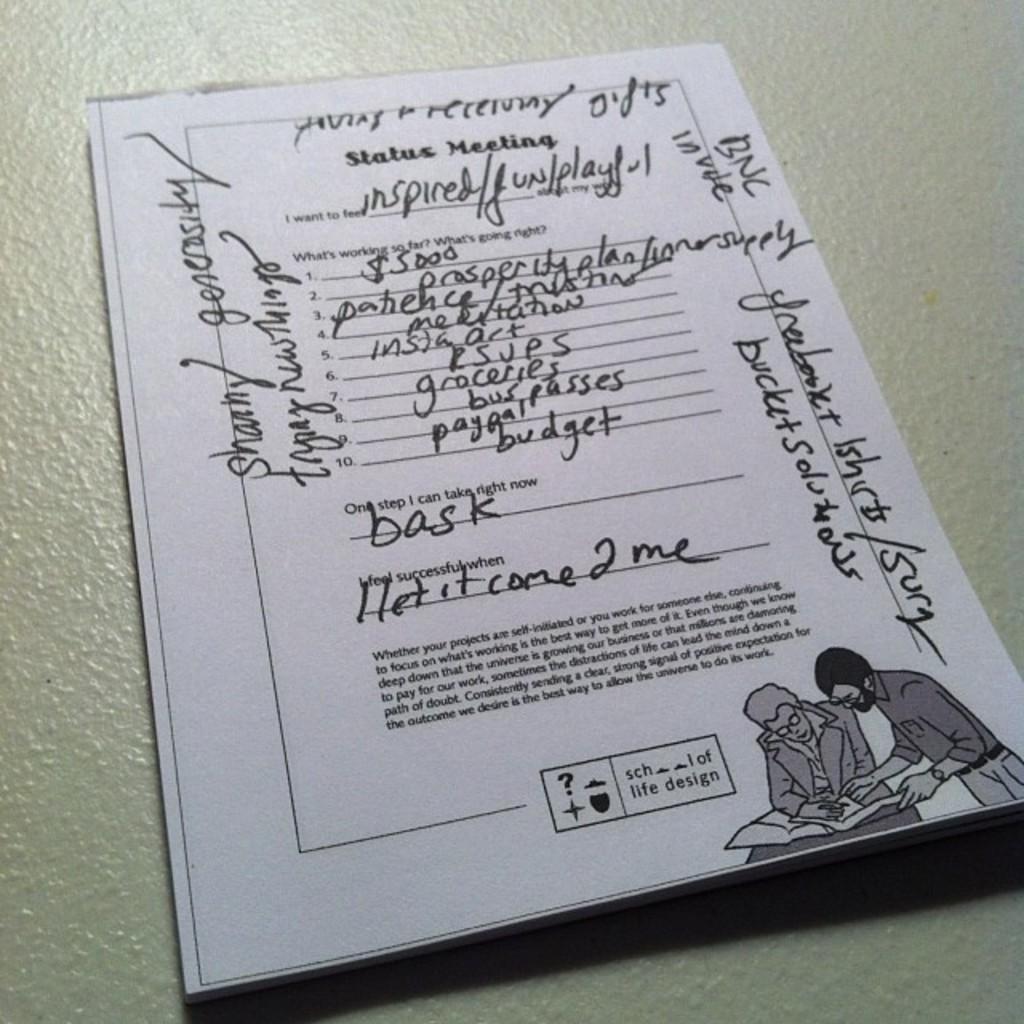Can you describe this image briefly? In this image we can see a book placed on the surface. 